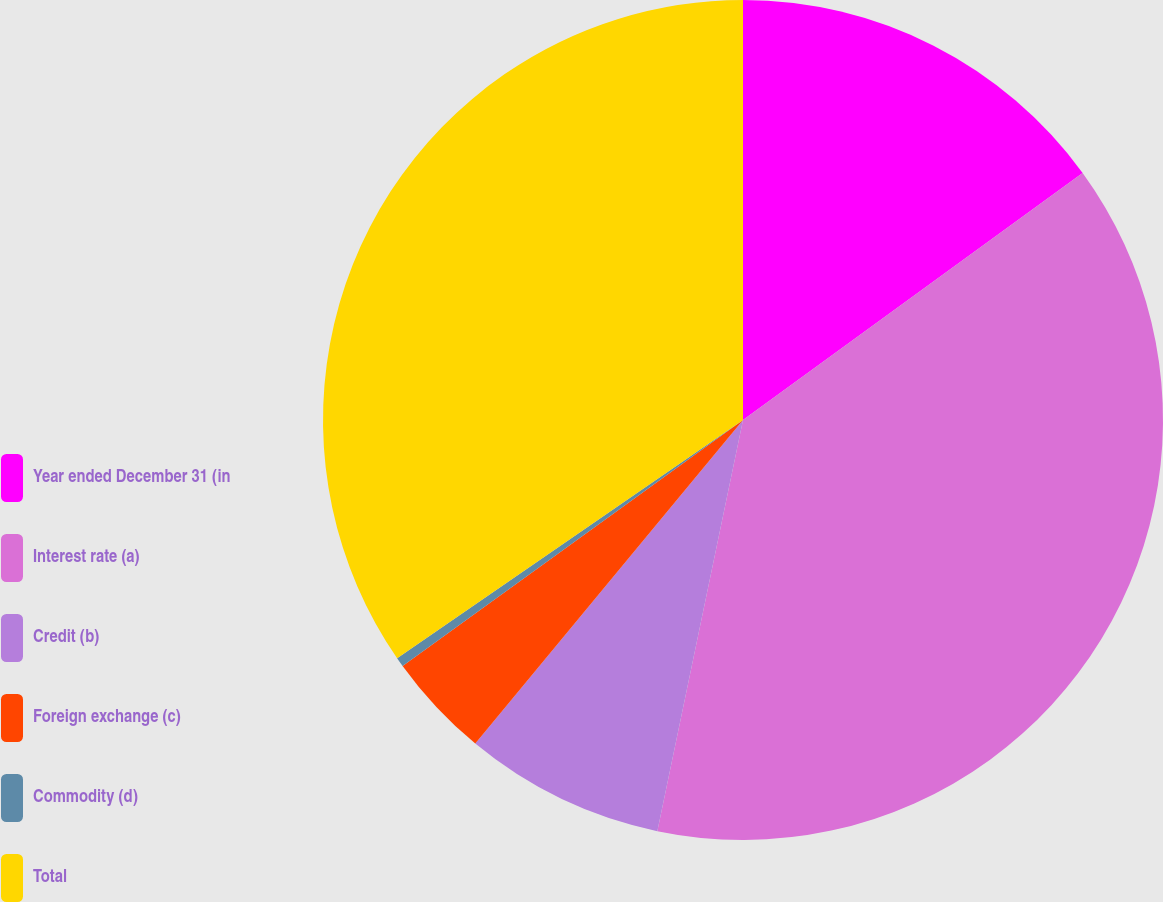Convert chart. <chart><loc_0><loc_0><loc_500><loc_500><pie_chart><fcel>Year ended December 31 (in<fcel>Interest rate (a)<fcel>Credit (b)<fcel>Foreign exchange (c)<fcel>Commodity (d)<fcel>Total<nl><fcel>14.99%<fcel>38.28%<fcel>7.73%<fcel>4.04%<fcel>0.36%<fcel>34.6%<nl></chart> 